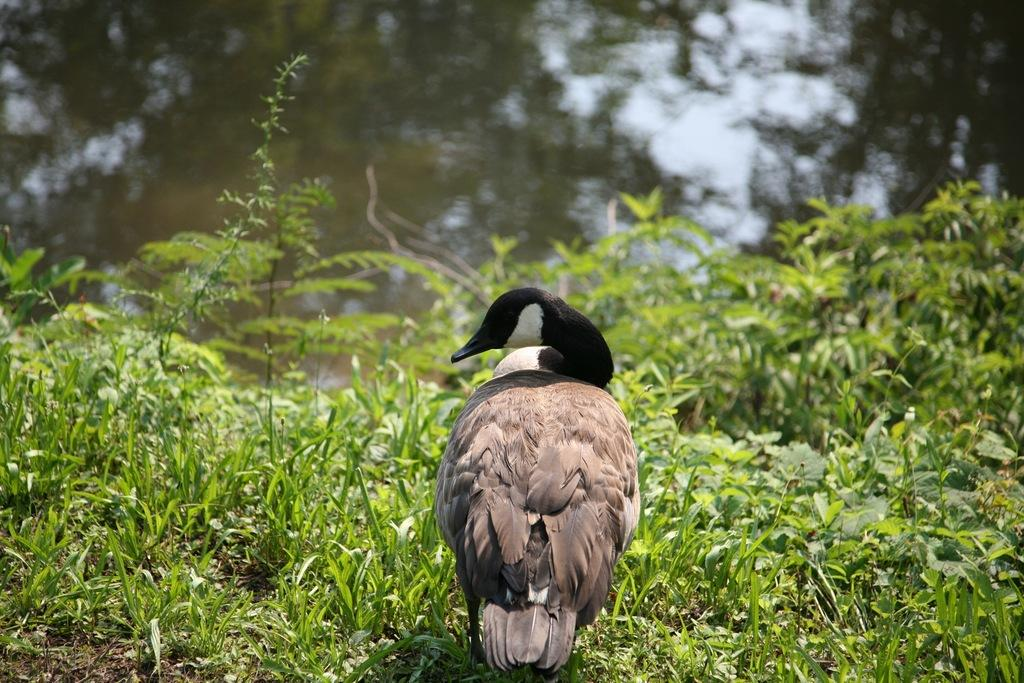What is the main subject in the front of the image? There is a bird in the front of the image. What can be seen at the bottom of the image? There are plants at the bottom of the image. What is visible in the background of the image? There is water visible in the background of the image. What type of powder is being used by the giants in the image? There are no giants or powder present in the image. 